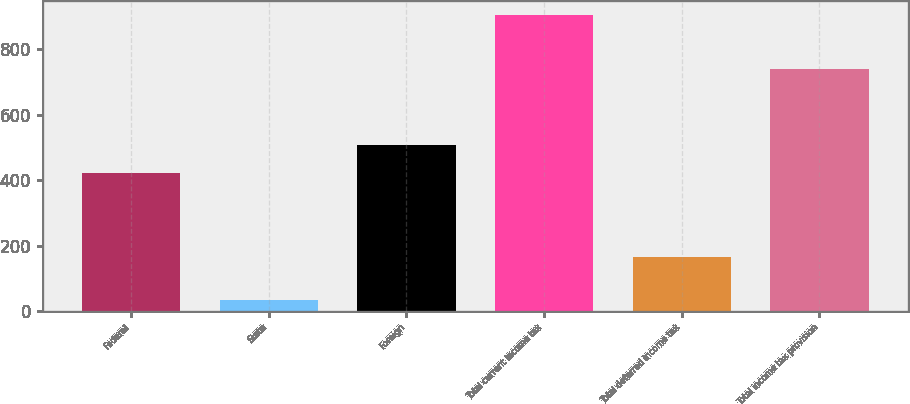<chart> <loc_0><loc_0><loc_500><loc_500><bar_chart><fcel>Federal<fcel>State<fcel>Foreign<fcel>Total current income tax<fcel>Total deferred income tax<fcel>Total income tax provision<nl><fcel>421<fcel>34<fcel>507.9<fcel>903<fcel>165<fcel>738<nl></chart> 